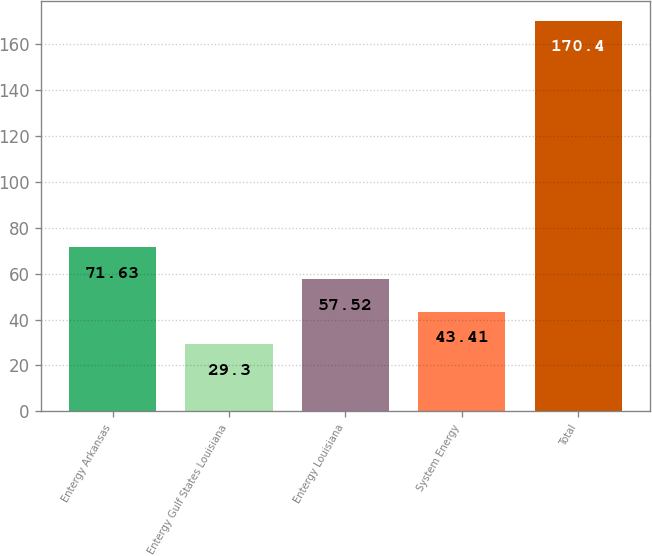Convert chart to OTSL. <chart><loc_0><loc_0><loc_500><loc_500><bar_chart><fcel>Entergy Arkansas<fcel>Entergy Gulf States Louisiana<fcel>Entergy Louisiana<fcel>System Energy<fcel>Total<nl><fcel>71.63<fcel>29.3<fcel>57.52<fcel>43.41<fcel>170.4<nl></chart> 